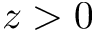<formula> <loc_0><loc_0><loc_500><loc_500>z > 0</formula> 